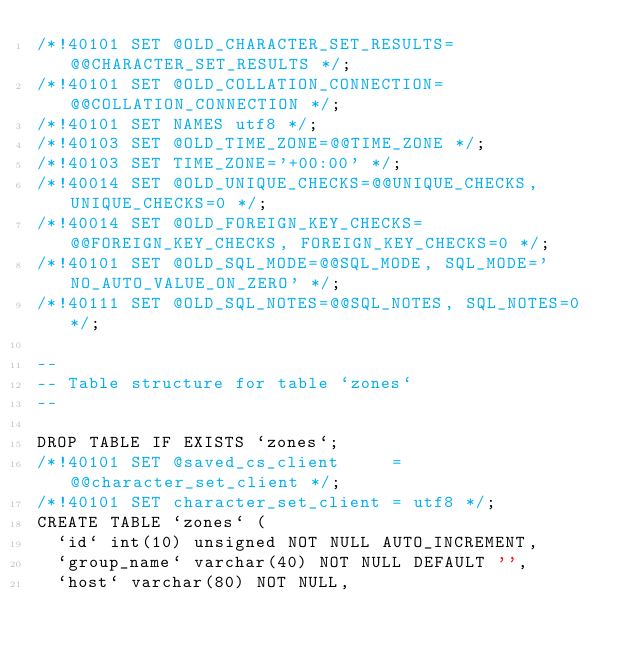Convert code to text. <code><loc_0><loc_0><loc_500><loc_500><_SQL_>/*!40101 SET @OLD_CHARACTER_SET_RESULTS=@@CHARACTER_SET_RESULTS */;
/*!40101 SET @OLD_COLLATION_CONNECTION=@@COLLATION_CONNECTION */;
/*!40101 SET NAMES utf8 */;
/*!40103 SET @OLD_TIME_ZONE=@@TIME_ZONE */;
/*!40103 SET TIME_ZONE='+00:00' */;
/*!40014 SET @OLD_UNIQUE_CHECKS=@@UNIQUE_CHECKS, UNIQUE_CHECKS=0 */;
/*!40014 SET @OLD_FOREIGN_KEY_CHECKS=@@FOREIGN_KEY_CHECKS, FOREIGN_KEY_CHECKS=0 */;
/*!40101 SET @OLD_SQL_MODE=@@SQL_MODE, SQL_MODE='NO_AUTO_VALUE_ON_ZERO' */;
/*!40111 SET @OLD_SQL_NOTES=@@SQL_NOTES, SQL_NOTES=0 */;

--
-- Table structure for table `zones`
--

DROP TABLE IF EXISTS `zones`;
/*!40101 SET @saved_cs_client     = @@character_set_client */;
/*!40101 SET character_set_client = utf8 */;
CREATE TABLE `zones` (
  `id` int(10) unsigned NOT NULL AUTO_INCREMENT,
  `group_name` varchar(40) NOT NULL DEFAULT '',
  `host` varchar(80) NOT NULL,</code> 